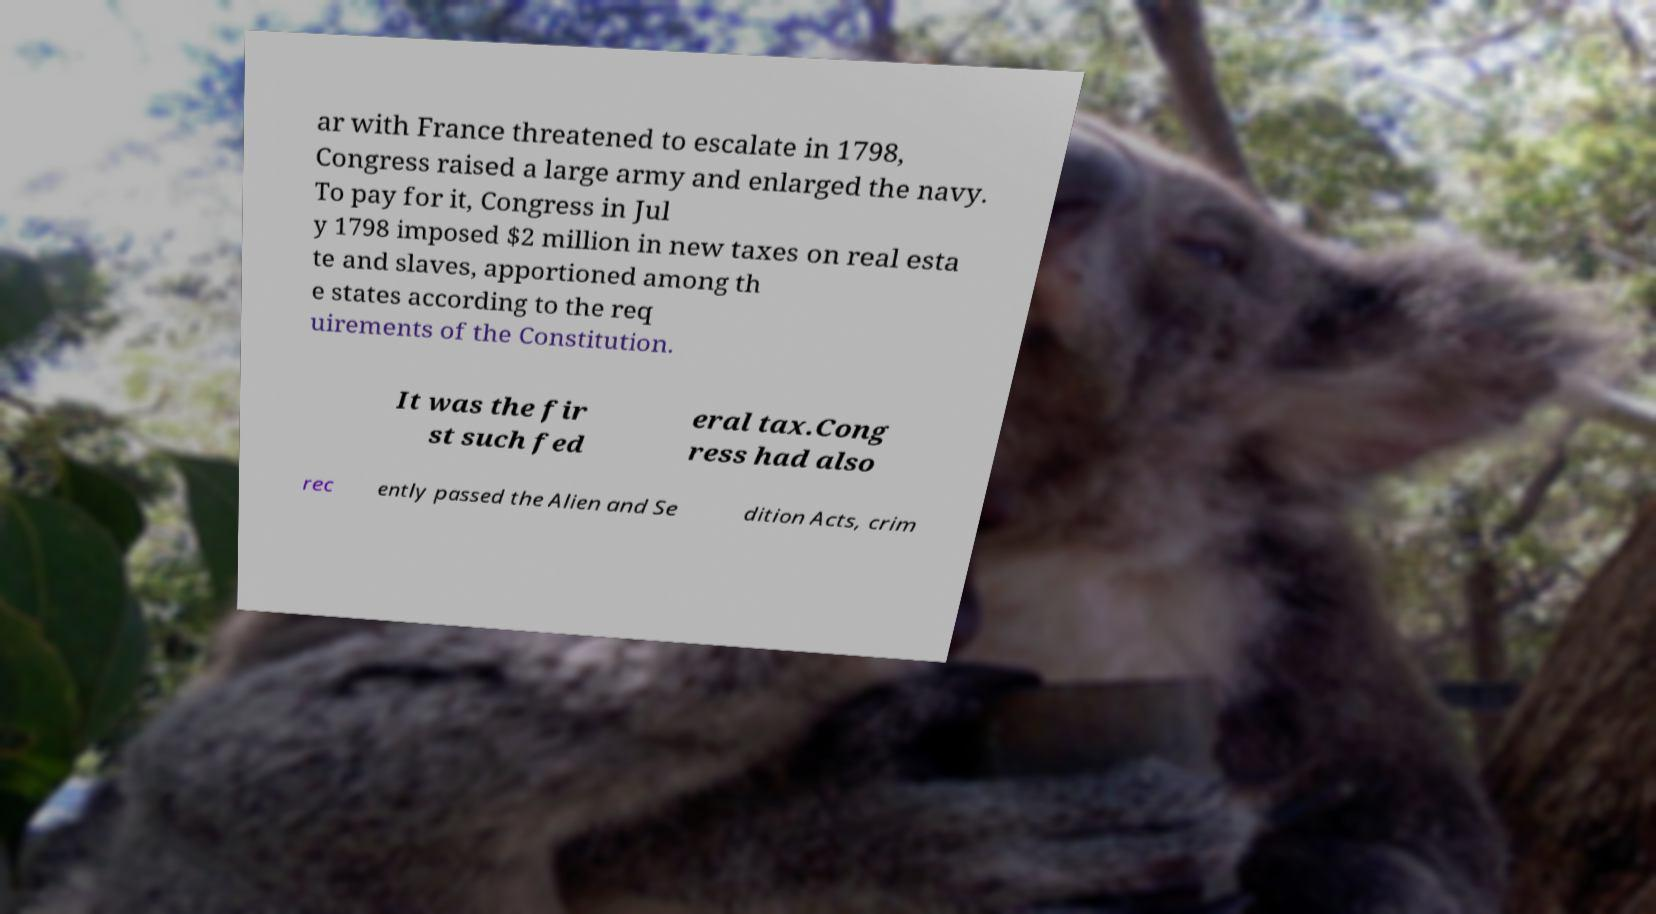For documentation purposes, I need the text within this image transcribed. Could you provide that? ar with France threatened to escalate in 1798, Congress raised a large army and enlarged the navy. To pay for it, Congress in Jul y 1798 imposed $2 million in new taxes on real esta te and slaves, apportioned among th e states according to the req uirements of the Constitution. It was the fir st such fed eral tax.Cong ress had also rec ently passed the Alien and Se dition Acts, crim 